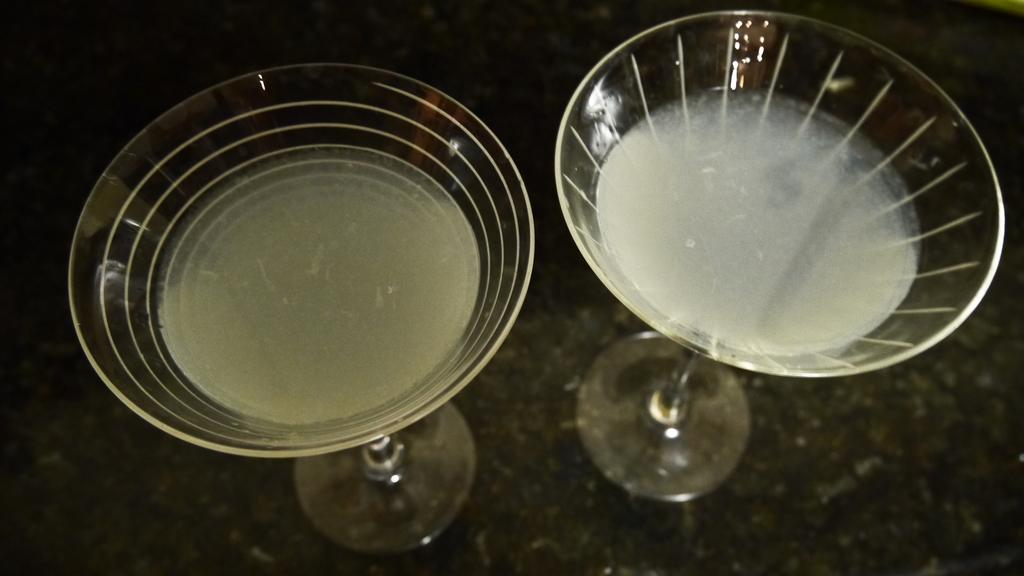What is inside the glasses in the image? There is liquid in the glasses. How many passengers are sitting on the squirrel in the image? There are no passengers or squirrels present in the image; it only features glasses with liquid in them. 